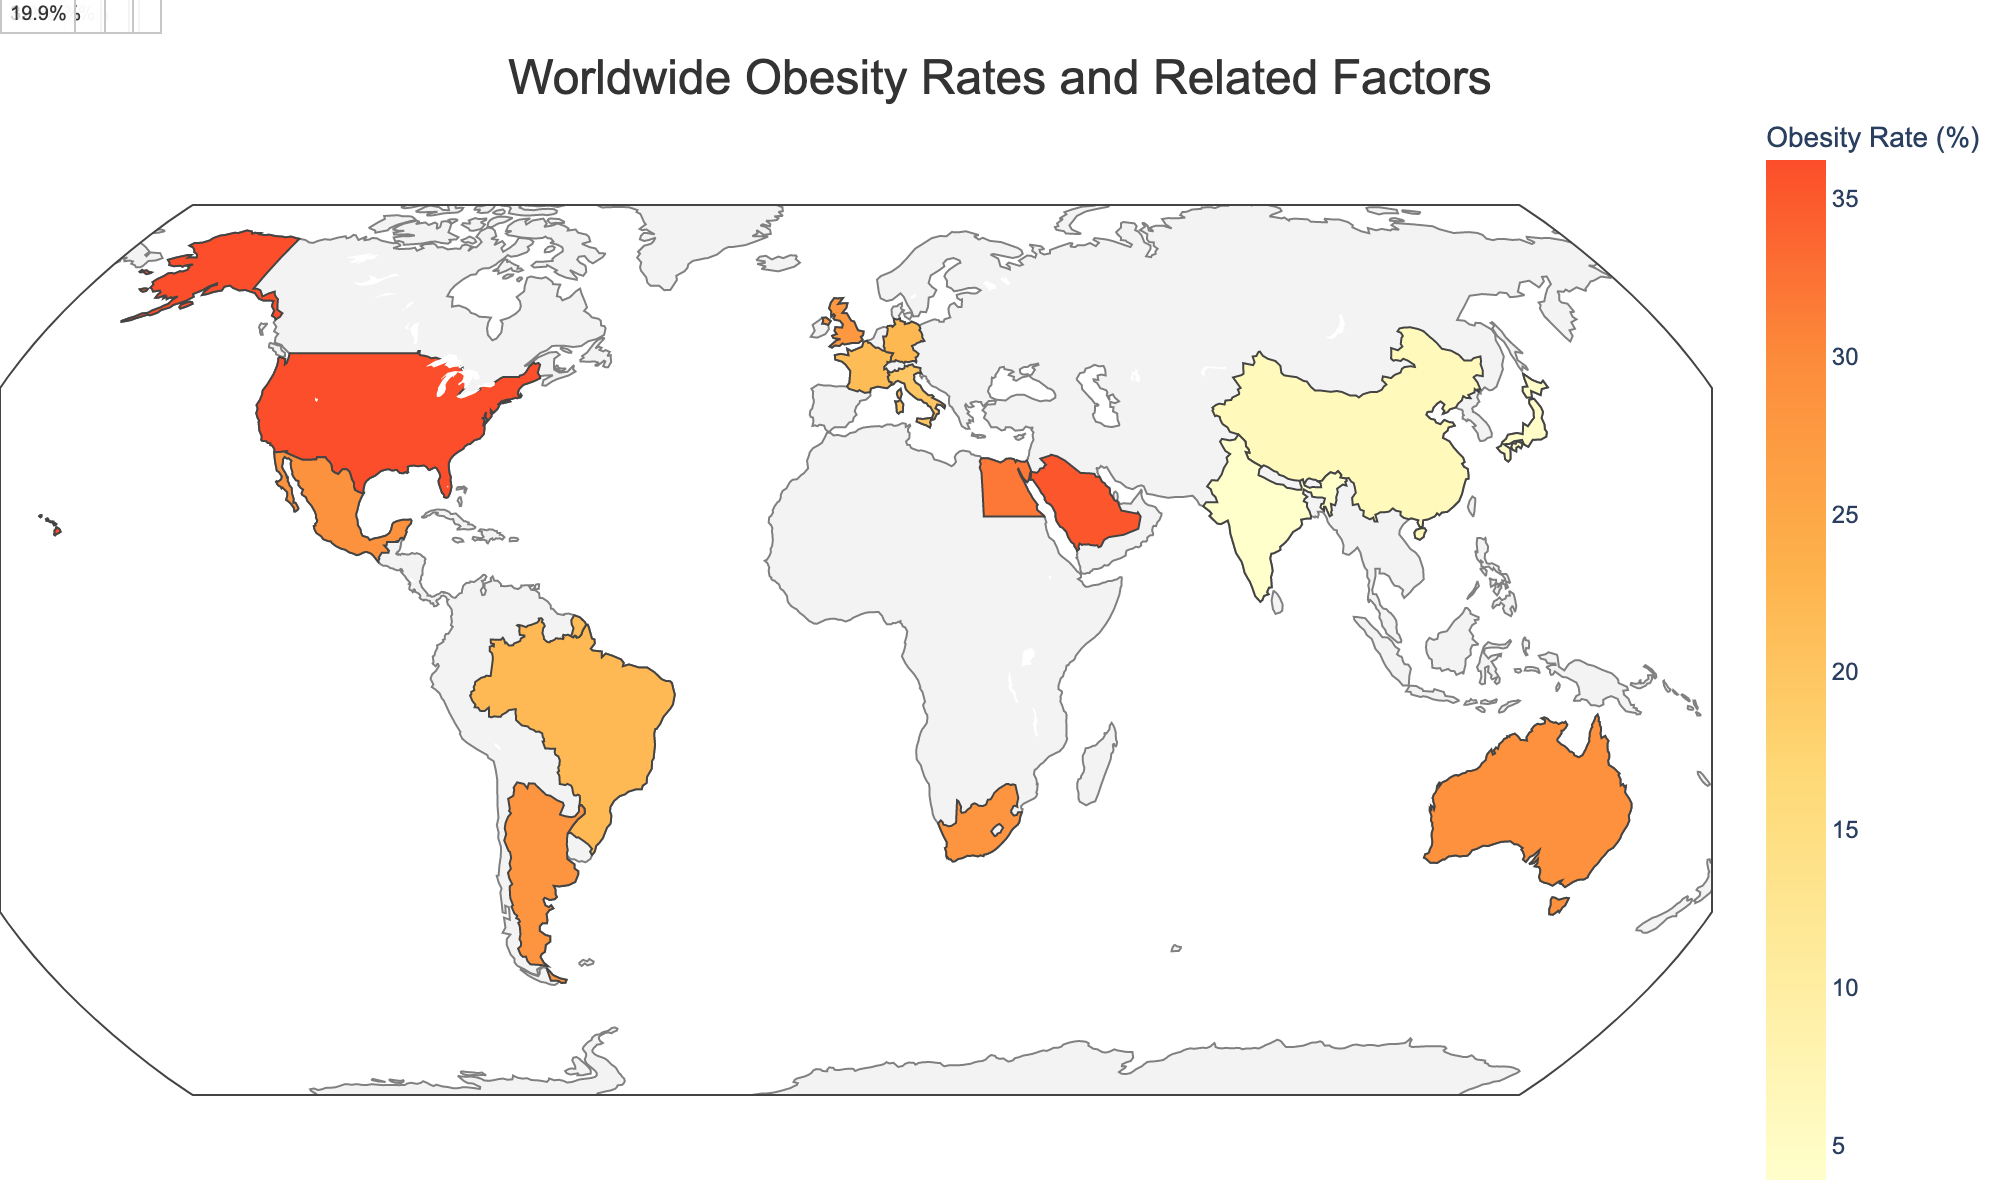How is the color of the countries determined on the map? The color of the countries is determined by the obesity rate, with a continuous color scale ranging from light shades for lower obesity rates to darker shades for higher rates.
Answer: By obesity rate What is the title of the geographic plot? The title of the geographic plot is displayed at the top of the figure.
Answer: Worldwide Obesity Rates and Related Factors Which country in North America has the highest obesity rate? By looking at North America, both the United States and Mexico are present. The obesity rate of the United States is 36.2%, while Mexico's is 28.9%. So, the United States has the highest rate.
Answer: United States Rank the countries in Europe by obesity rate from highest to lowest. In Europe, the obesity rates are as follows: United Kingdom (27.8%), Germany (22.3%), France (21.6%), and Italy (19.9%). Arranged from highest to lowest, they are United Kingdom, Germany, France, and Italy.
Answer: United Kingdom, Germany, France, Italy Which region has the highest average obesity rate? Calculate the average obesity rate for each region: 
- North America: (36.2 + 28.9) / 2 = 32.55%
- Europe: (27.8 + 22.3 + 21.6 + 19.9) / 4 = 22.9%
- Asia: (4.3 + 6.2 + 3.9) / 3 = 4.8%
- South America: (22.1 + 28.3) / 2 = 25.2%
- Africa: (28.3 + 32.0) / 2 = 30.15%
- Oceania: 29.0%
- Middle East: 35.4%
The highest average is North America at 32.55%.
Answer: North America Which country has the lowest GDP per capita and what is its obesity rate? India's GDP per capita is the lowest at 1901. Its obesity rate is displayed as 3.9%.
Answer: India, 3.9% What is the relationship between fast food outlets per 100k people and obesity rate across the countries? By examining the data, it appears countries with more fast food outlets per 100k (like the United States with 81.2 outlets and an obesity rate of 36.2%) generally have higher obesity rates, whereas countries with fewer outlets (like India with 5.7 outlets and an obesity rate of 3.9%) tend to have lower obesity rates. This suggests a positive correlation between the number of fast-food outlets per capita and obesity rates.
Answer: Positive correlation Which country in Africa has the highest obesity rate and what is its GDP per capita? By looking at Africa, there are South Africa (28.3%) and Egypt (32.0%). Egypt has the higher rate with 32.0%, and its GDP per capita is 3547.
Answer: Egypt, 3547 